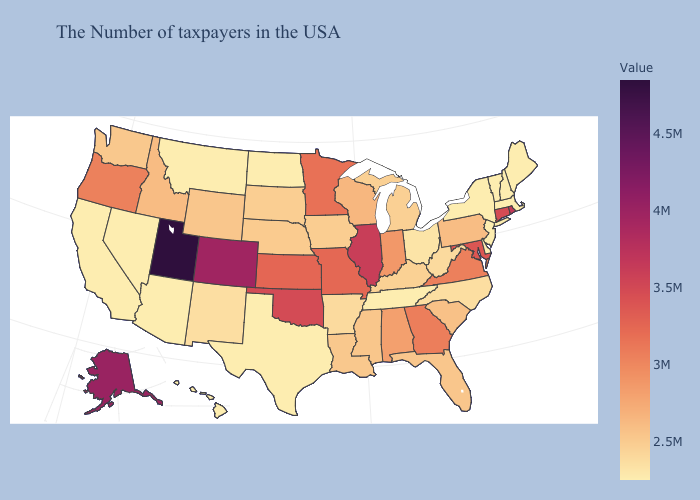Does Georgia have the lowest value in the South?
Keep it brief. No. Does the map have missing data?
Quick response, please. No. Does the map have missing data?
Give a very brief answer. No. Does Wisconsin have the lowest value in the MidWest?
Keep it brief. No. Among the states that border Illinois , which have the lowest value?
Give a very brief answer. Kentucky. 